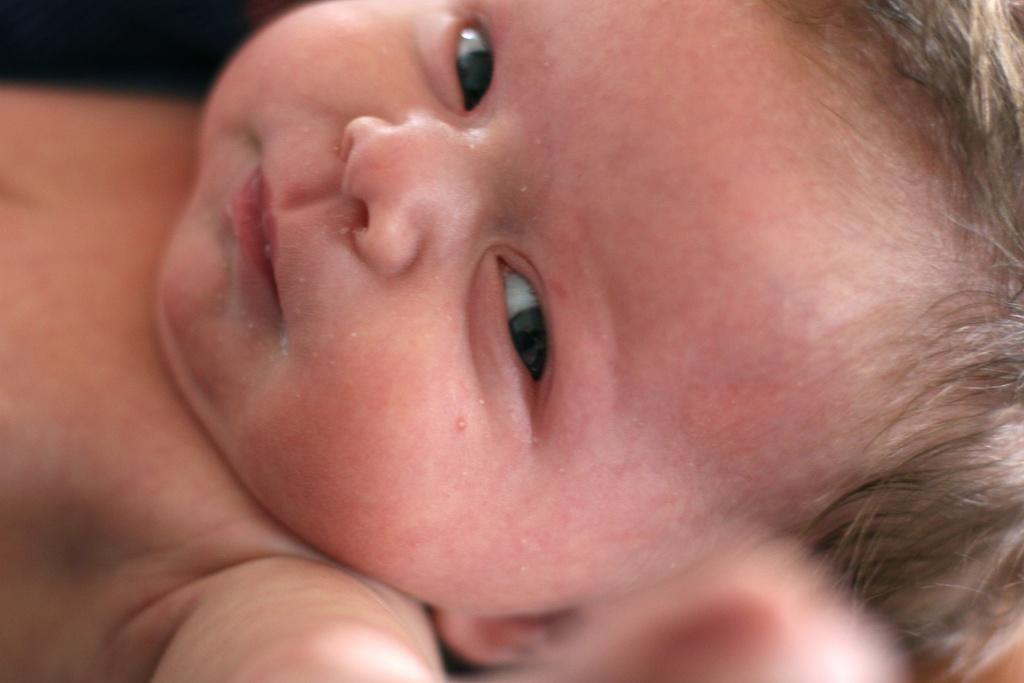What is the main subject of the image? There is a baby in the image. Where is the nest located in the image? There is no nest present in the image. What type of chess piece is the baby holding in the image? There is no chess piece or any indication of a game of chess in the image. 